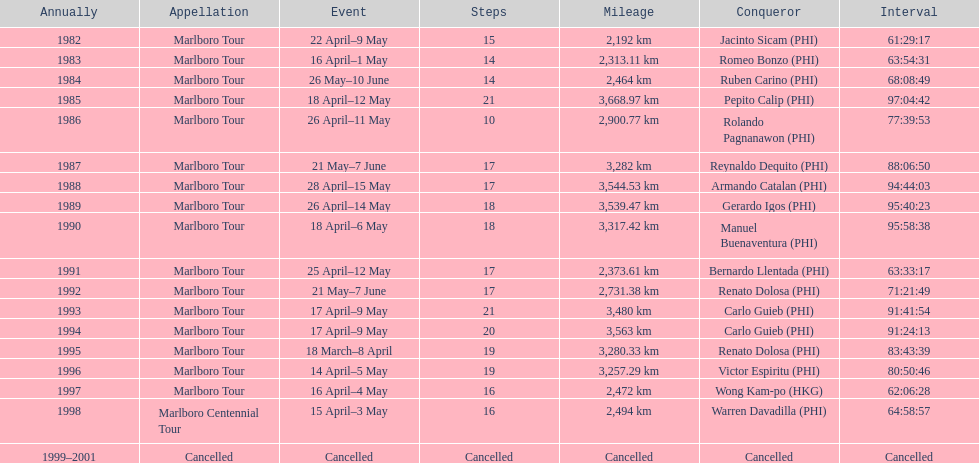Who is listed before wong kam-po? Victor Espiritu (PHI). 